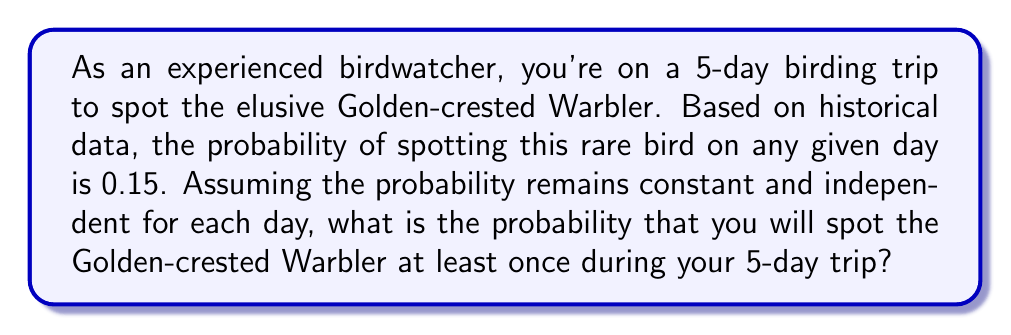Can you answer this question? Let's approach this step-by-step:

1. First, we need to understand what we're calculating. We want the probability of spotting the bird at least once in 5 days, which is easier to calculate by subtracting the probability of not spotting the bird at all from 1.

2. The probability of not spotting the bird on a single day is:
   $1 - 0.15 = 0.85$

3. For the bird to not be spotted at all in 5 days, it must not be spotted on day 1 AND day 2 AND day 3 AND day 4 AND day 5. Since the events are independent, we multiply these probabilities:

   $P(\text{no sightings in 5 days}) = 0.85 \times 0.85 \times 0.85 \times 0.85 \times 0.85 = 0.85^5$

4. We can calculate this:
   $0.85^5 \approx 0.4437$

5. Now, the probability of spotting the bird at least once is the opposite of not spotting it at all:

   $P(\text{at least one sighting}) = 1 - P(\text{no sightings})$
   $= 1 - 0.85^5$
   $= 1 - 0.4437$
   $\approx 0.5563$

6. Converting to a percentage:
   $0.5563 \times 100\% \approx 55.63\%$

Therefore, the probability of spotting the Golden-crested Warbler at least once during the 5-day trip is approximately 55.63%.
Answer: The probability of spotting the Golden-crested Warbler at least once during the 5-day trip is approximately 55.63% or 0.5563. 